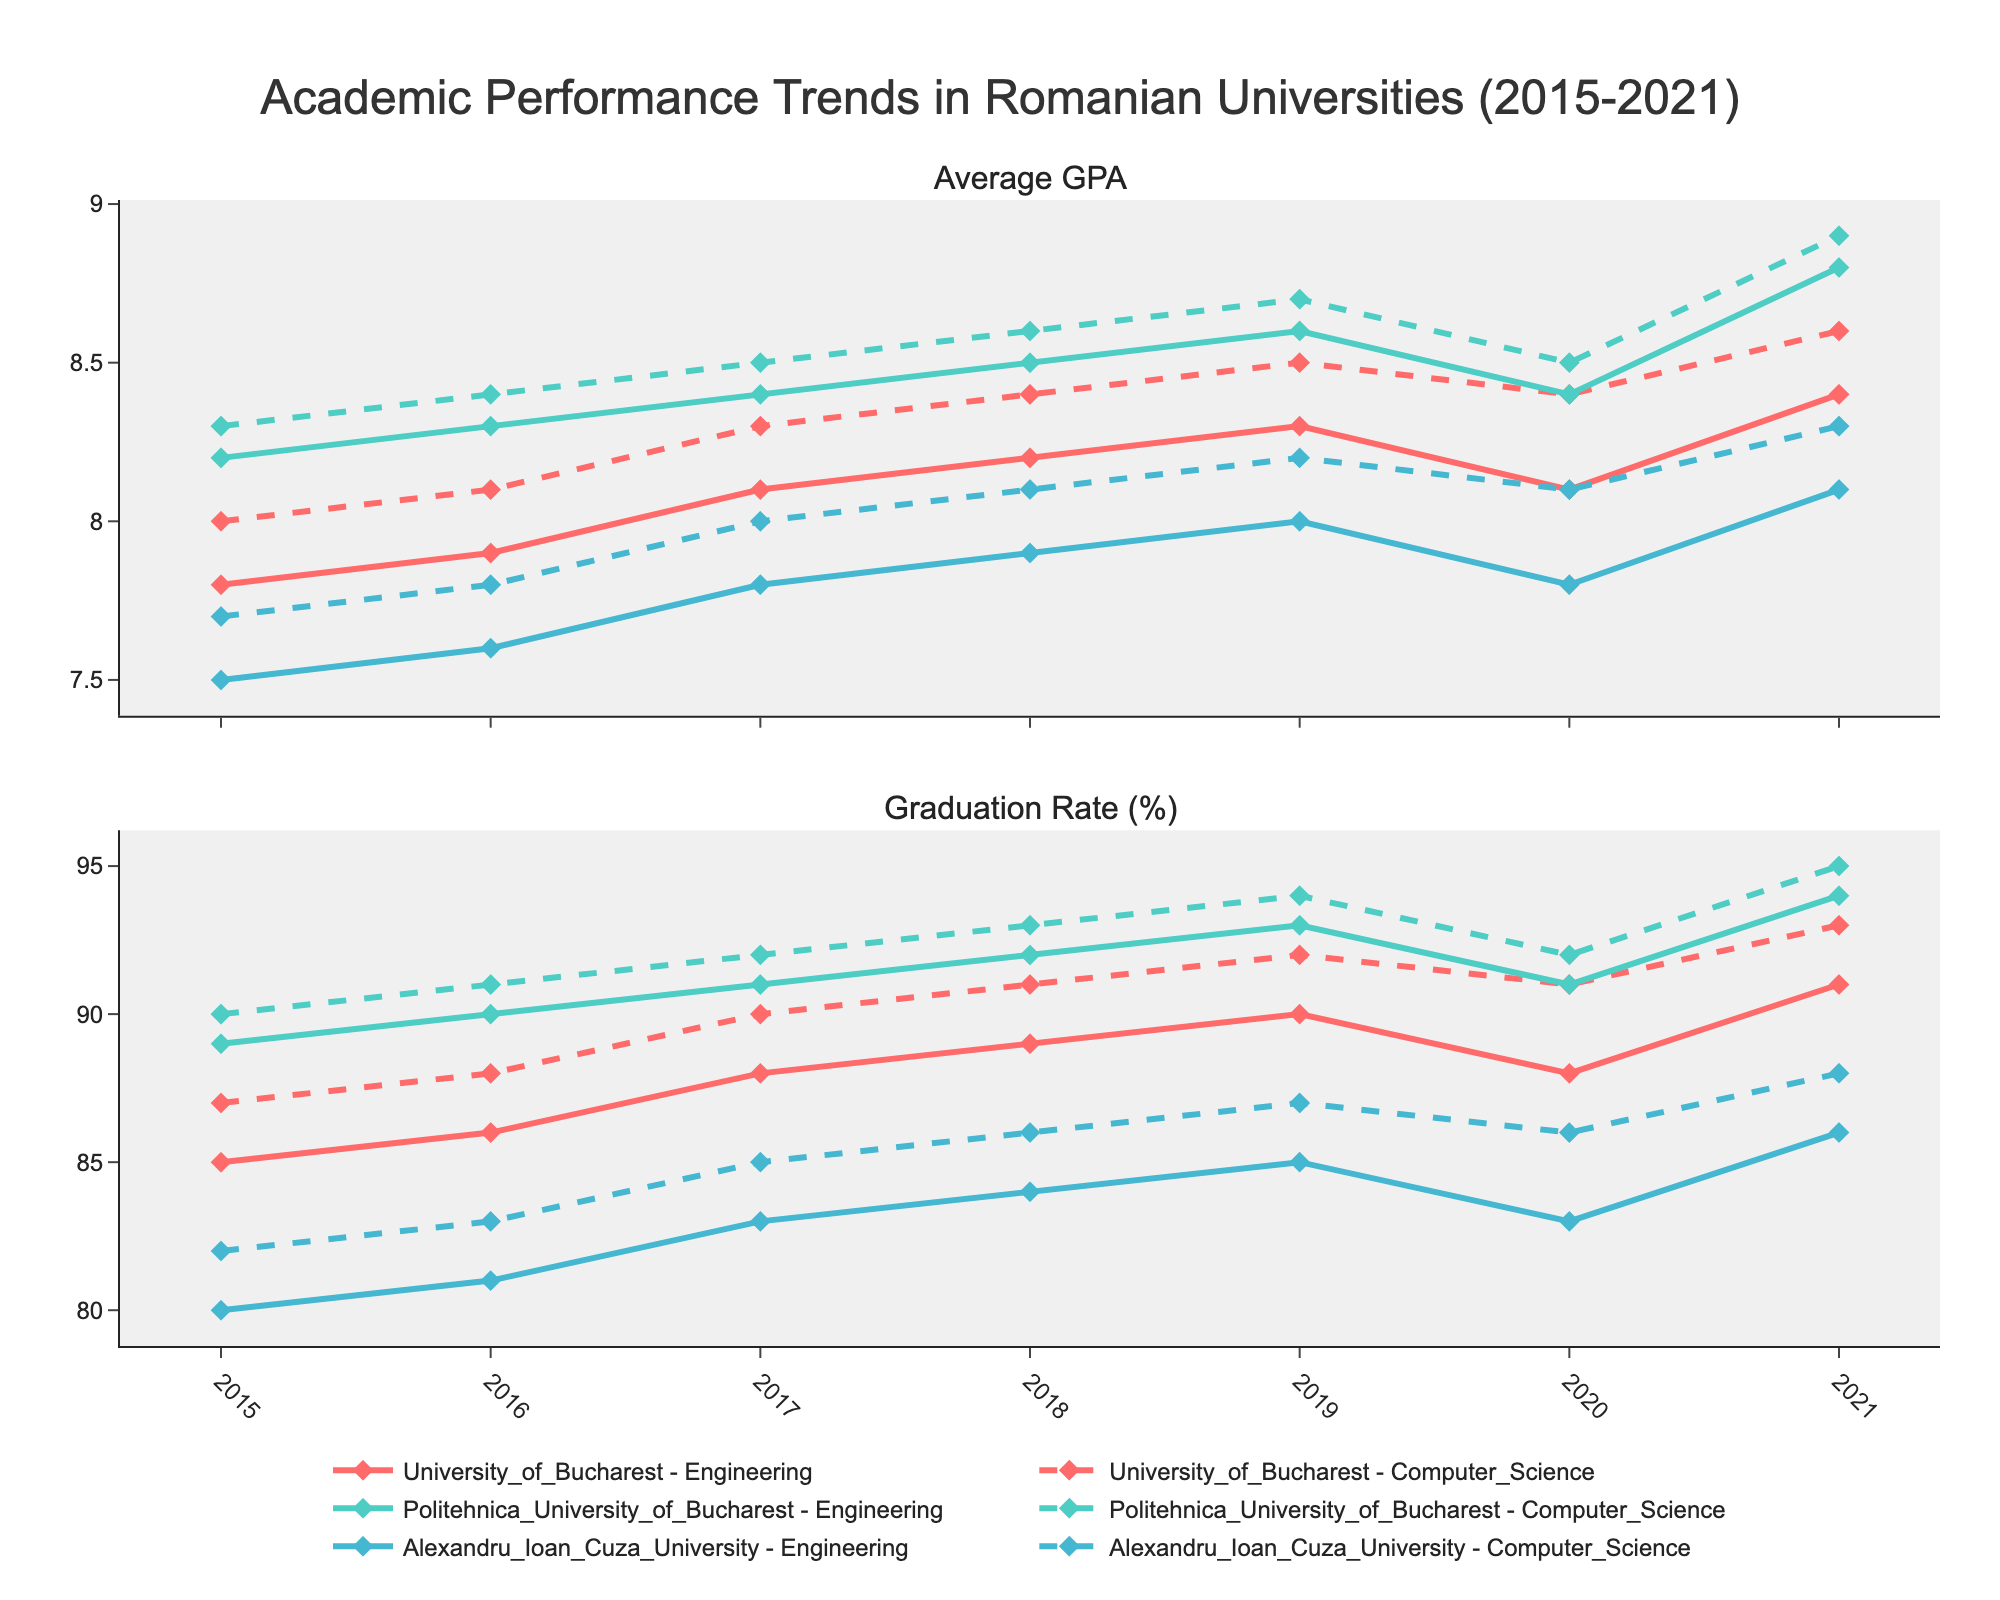What is the overall title of the figure? The title is usually positioned at the top of the figure and gives a summary of the plot's content. This plot's title combines information about academic performance trends, Romanian universities, the timeframe (2015-2021), and the specific departments of focus (Engineering and Computer Science).
Answer: Academic Performance Trends in Romanian Universities (2015-2021) What are the two main metrics plotted on the figure? The subplot titles indicate the two main metrics. The first subplot title refers to 'Average GPA,' and the second subplot title refers to 'Graduation Rate (%).'
Answer: Average GPA and Graduation Rate (%) Which university had the highest graduation rate for Engineering in 2021? To find this, look at the graduation rate subplot in 2021 for the Engineering departments and compare the lines representing different universities. The trace labeled 'Politehnica_University_of_Bucharest - Engineering' is highest.
Answer: Politehnica University of Bucharest Did the average GPA for the Computer Science department at Alexandru Ioan Cuza University increase or decrease from 2019 to 2020? Track the 'Alexandru_Ioan_Cuza_University - Computer_Science' line in the first subplot from 2019 to 2020. The GPA goes from 8.2 in 2019 to 8.1 in 2020, indicating a decrease.
Answer: Decrease How did the graduation rate of Engineering at University of Bucharest change from 2019 to 2020? Find the 'University_of_Bucharest - Engineering' in the graduation rate subplot and follow the trace from 2019 to 2020. The graduation rate decreases from 90% in 2019 to 88% in 2020.
Answer: Decrease Which department had a consistently higher average GPA at Politehnica University of Bucharest, Engineering or Computer Science? Compare the traces for Politehnica University of Bucharest in the Average GPA subplot. The line for 'Computer_Science' is consistently higher than 'Engineering' in all years.
Answer: Computer Science What is the trend for the graduation rate of Computer Science at University of Bucharest from 2015 to 2021? The trace for 'University_of_Bucharest - Computer_Science' in the graduation rate subplot shows a consistent rise from 87% in 2015 to 93% in 2021, indicating an upward trend.
Answer: Upward By how much did the average GPA of Engineering at Politehnica University of Bucharest change from 2015 to 2021? Check the 'Politehnica_University_of_Bucharest - Engineering' line in the Average GPA subplot. In 2015, the GPA was 8.2, and in 2021 it was 8.8. The change is 8.8 - 8.2 = 0.6.
Answer: 0.6 Which university shows the most variation in graduation rates for Engineering from 2015 to 2021? Review the graduation rate subplot and observe the range of graduation rates for each university's Engineering department. The 'University_of_Bucharest - Engineering' line shows a range from 85% to 91%, indicating notable variation.
Answer: University of Bucharest Between University of Bucharest and Alexandru Ioan Cuza University, which had a higher average GPA in Computer Science for the year 2017? Look at the average GPA subplot, specifically for 2017, and compare 'University_of_Bucharest - Computer_Science' and 'Alexandru_Ioan_Cuza_University - Computer_Science.' University of Bucharest is higher with 8.3 compared to 8.0.
Answer: University of Bucharest 